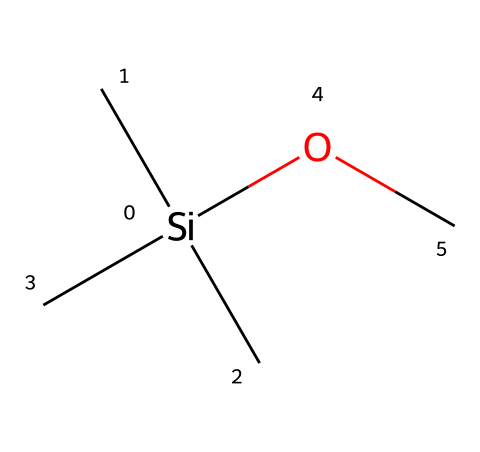What is the central atom in this chemical? The central atom in the chemical structure is silicon, identified by the element symbol "Si" at the heart of the arrangement.
Answer: silicon How many carbon atoms are present in this chemical? The chemical structure contains three carbon atoms, represented by the three "C" symbols attached to the silicon atom.
Answer: three What type of functional group is represented in this chemical? The structure includes a methoxy group (-OCH3), as indicated by the "OC" part connected to silicon.
Answer: methoxy How many total bonds does the silicon atom form in this structure? The silicon atom forms four total bonds: three bonds with the carbon atoms and one bond with the oxygen atom.
Answer: four What is the general class of this chemical compound? This compound belongs to the organosilicon class due to the presence of silicon connected to carbon and an organic functional group.
Answer: organosilicon Which atom in this chemical contributes to its potential use in electronic devices? The silicon atom contributes to its functions in electronic devices due to its semiconductor properties.
Answer: silicon What is the hybridization state of the silicon atom in this compound? The silicon atom is tetrahedral hybridized, allowing it to form four equivalent bonds with the surrounding atoms in the compound.
Answer: tetrahedral 